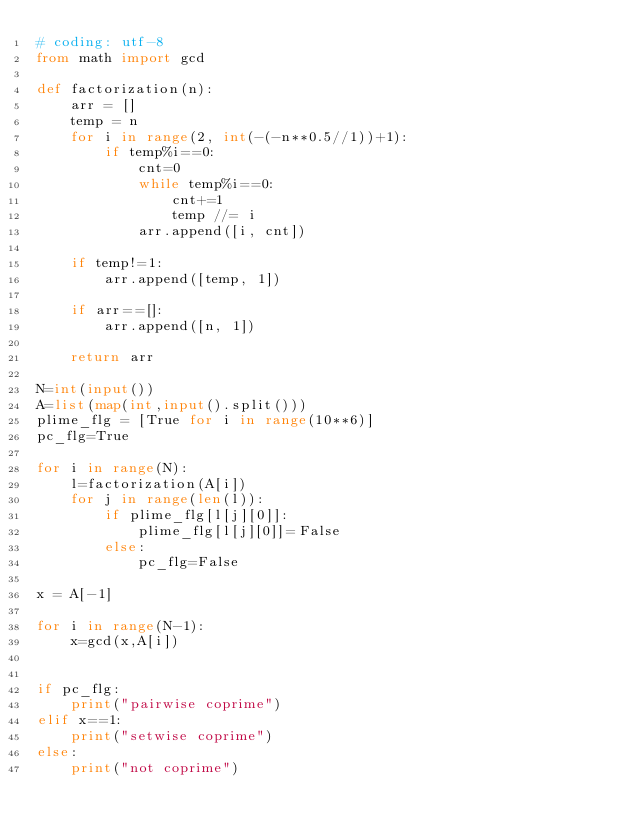Convert code to text. <code><loc_0><loc_0><loc_500><loc_500><_Python_># coding: utf-8
from math import gcd

def factorization(n):
    arr = []
    temp = n
    for i in range(2, int(-(-n**0.5//1))+1):
        if temp%i==0:
            cnt=0
            while temp%i==0:
                cnt+=1
                temp //= i
            arr.append([i, cnt])

    if temp!=1:
        arr.append([temp, 1])

    if arr==[]:
        arr.append([n, 1])

    return arr

N=int(input())
A=list(map(int,input().split()))
plime_flg = [True for i in range(10**6)]
pc_flg=True

for i in range(N):
    l=factorization(A[i])
    for j in range(len(l)):
        if plime_flg[l[j][0]]:
            plime_flg[l[j][0]]=False
        else:
            pc_flg=False

x = A[-1]

for i in range(N-1):
    x=gcd(x,A[i])


if pc_flg:
    print("pairwise coprime")
elif x==1:
    print("setwise coprime")
else:
    print("not coprime")


</code> 